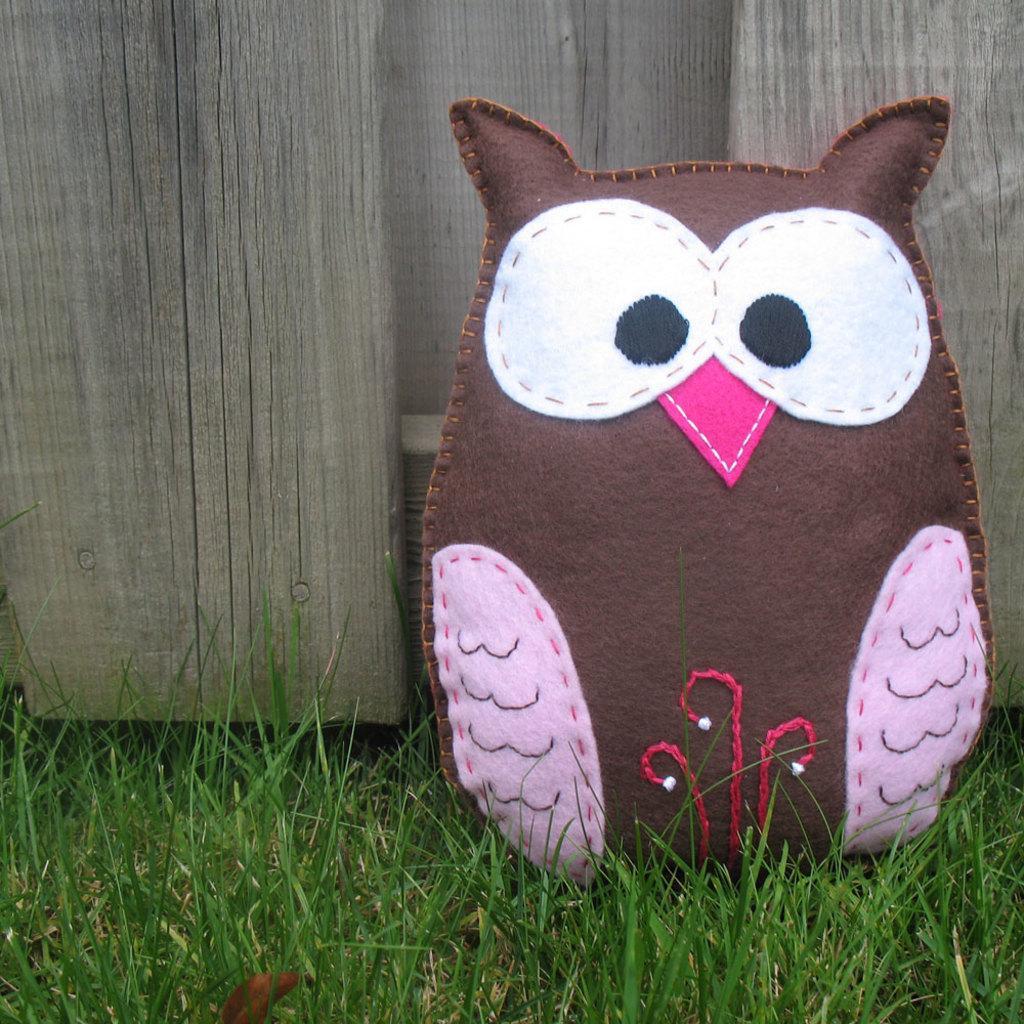How would you summarize this image in a sentence or two? In this picture I can see a cushion looks like a owl, on the ground and I can see grass and wood in the background. 